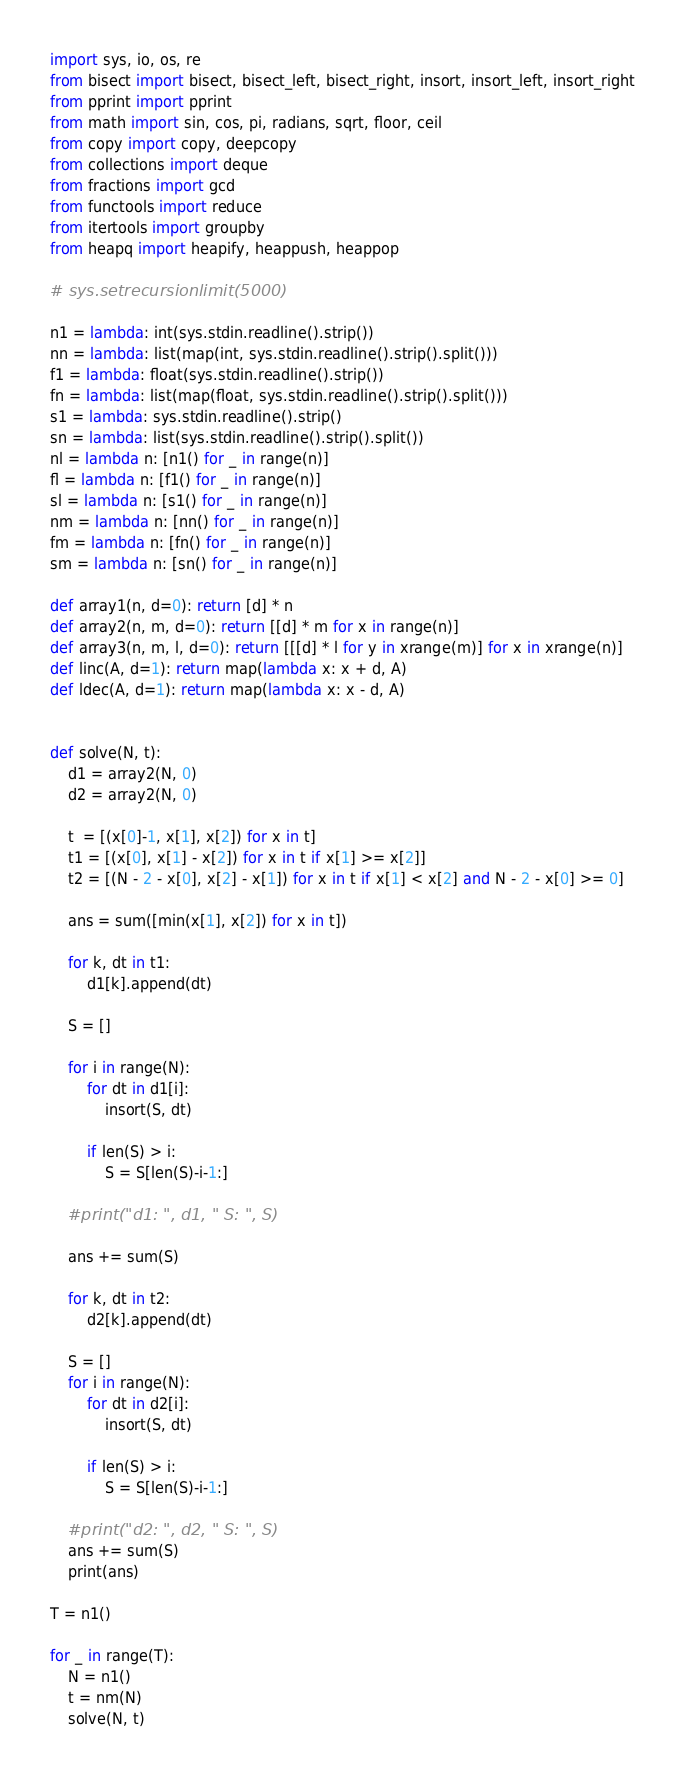<code> <loc_0><loc_0><loc_500><loc_500><_Python_>import sys, io, os, re
from bisect import bisect, bisect_left, bisect_right, insort, insort_left, insort_right
from pprint import pprint
from math import sin, cos, pi, radians, sqrt, floor, ceil
from copy import copy, deepcopy
from collections import deque
from fractions import gcd
from functools import reduce
from itertools import groupby
from heapq import heapify, heappush, heappop

# sys.setrecursionlimit(5000)

n1 = lambda: int(sys.stdin.readline().strip())
nn = lambda: list(map(int, sys.stdin.readline().strip().split()))
f1 = lambda: float(sys.stdin.readline().strip())
fn = lambda: list(map(float, sys.stdin.readline().strip().split()))
s1 = lambda: sys.stdin.readline().strip()
sn = lambda: list(sys.stdin.readline().strip().split())
nl = lambda n: [n1() for _ in range(n)]
fl = lambda n: [f1() for _ in range(n)]
sl = lambda n: [s1() for _ in range(n)]
nm = lambda n: [nn() for _ in range(n)]
fm = lambda n: [fn() for _ in range(n)]
sm = lambda n: [sn() for _ in range(n)]

def array1(n, d=0): return [d] * n
def array2(n, m, d=0): return [[d] * m for x in range(n)]
def array3(n, m, l, d=0): return [[[d] * l for y in xrange(m)] for x in xrange(n)]
def linc(A, d=1): return map(lambda x: x + d, A)
def ldec(A, d=1): return map(lambda x: x - d, A)


def solve(N, t):
    d1 = array2(N, 0)
    d2 = array2(N, 0)

    t  = [(x[0]-1, x[1], x[2]) for x in t]
    t1 = [(x[0], x[1] - x[2]) for x in t if x[1] >= x[2]]
    t2 = [(N - 2 - x[0], x[2] - x[1]) for x in t if x[1] < x[2] and N - 2 - x[0] >= 0]

    ans = sum([min(x[1], x[2]) for x in t])
    
    for k, dt in t1:
        d1[k].append(dt)

    S = []

    for i in range(N):
        for dt in d1[i]:
            insort(S, dt)

        if len(S) > i:
            S = S[len(S)-i-1:]

    #print("d1: ", d1, " S: ", S)

    ans += sum(S)

    for k, dt in t2:
        d2[k].append(dt)

    S = []
    for i in range(N):
        for dt in d2[i]:
            insort(S, dt)

        if len(S) > i:        
            S = S[len(S)-i-1:]

    #print("d2: ", d2, " S: ", S)
    ans += sum(S)
    print(ans)

T = n1()

for _ in range(T):
    N = n1()
    t = nm(N)
    solve(N, t)</code> 